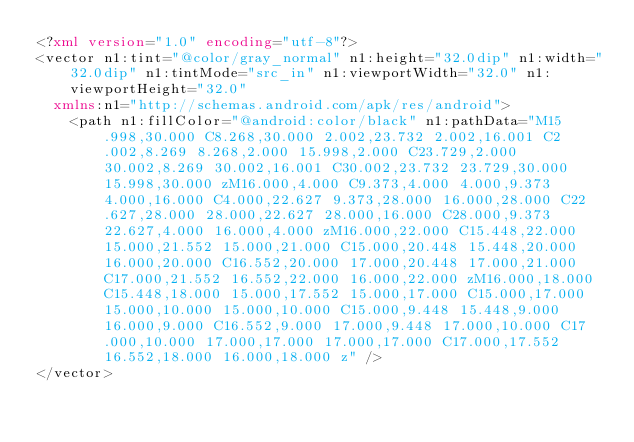Convert code to text. <code><loc_0><loc_0><loc_500><loc_500><_XML_><?xml version="1.0" encoding="utf-8"?>
<vector n1:tint="@color/gray_normal" n1:height="32.0dip" n1:width="32.0dip" n1:tintMode="src_in" n1:viewportWidth="32.0" n1:viewportHeight="32.0"
  xmlns:n1="http://schemas.android.com/apk/res/android">
    <path n1:fillColor="@android:color/black" n1:pathData="M15.998,30.000 C8.268,30.000 2.002,23.732 2.002,16.001 C2.002,8.269 8.268,2.000 15.998,2.000 C23.729,2.000 30.002,8.269 30.002,16.001 C30.002,23.732 23.729,30.000 15.998,30.000 zM16.000,4.000 C9.373,4.000 4.000,9.373 4.000,16.000 C4.000,22.627 9.373,28.000 16.000,28.000 C22.627,28.000 28.000,22.627 28.000,16.000 C28.000,9.373 22.627,4.000 16.000,4.000 zM16.000,22.000 C15.448,22.000 15.000,21.552 15.000,21.000 C15.000,20.448 15.448,20.000 16.000,20.000 C16.552,20.000 17.000,20.448 17.000,21.000 C17.000,21.552 16.552,22.000 16.000,22.000 zM16.000,18.000 C15.448,18.000 15.000,17.552 15.000,17.000 C15.000,17.000 15.000,10.000 15.000,10.000 C15.000,9.448 15.448,9.000 16.000,9.000 C16.552,9.000 17.000,9.448 17.000,10.000 C17.000,10.000 17.000,17.000 17.000,17.000 C17.000,17.552 16.552,18.000 16.000,18.000 z" />
</vector></code> 